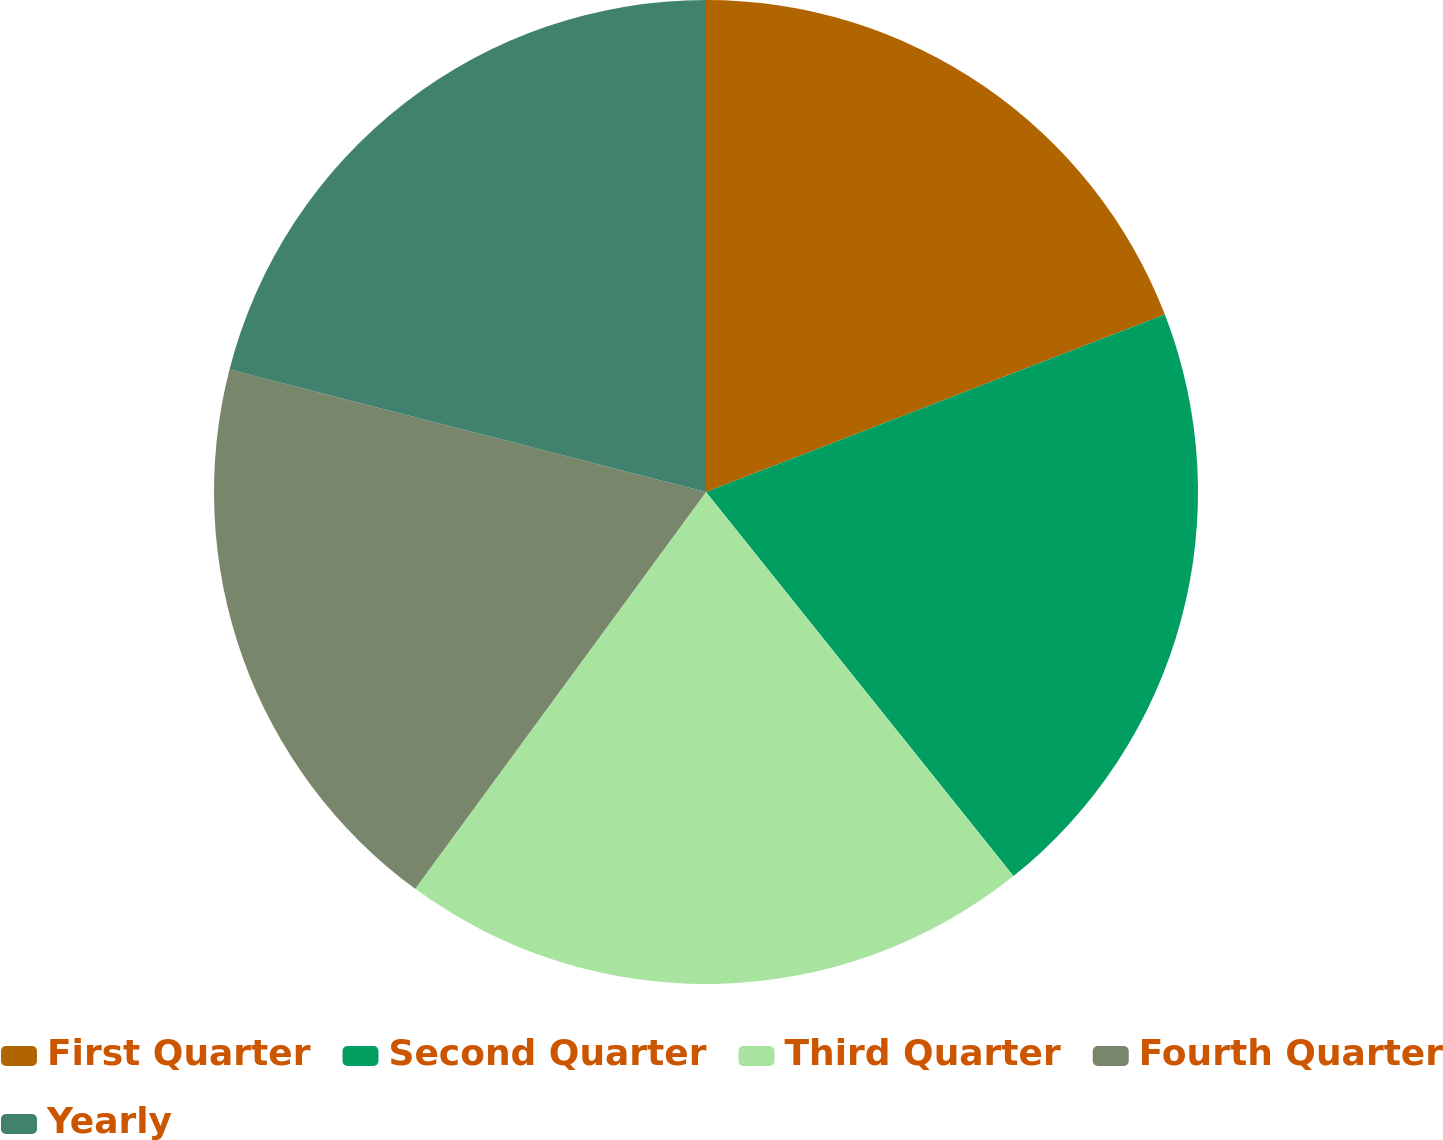Convert chart. <chart><loc_0><loc_0><loc_500><loc_500><pie_chart><fcel>First Quarter<fcel>Second Quarter<fcel>Third Quarter<fcel>Fourth Quarter<fcel>Yearly<nl><fcel>19.13%<fcel>20.13%<fcel>20.81%<fcel>18.94%<fcel>21.0%<nl></chart> 